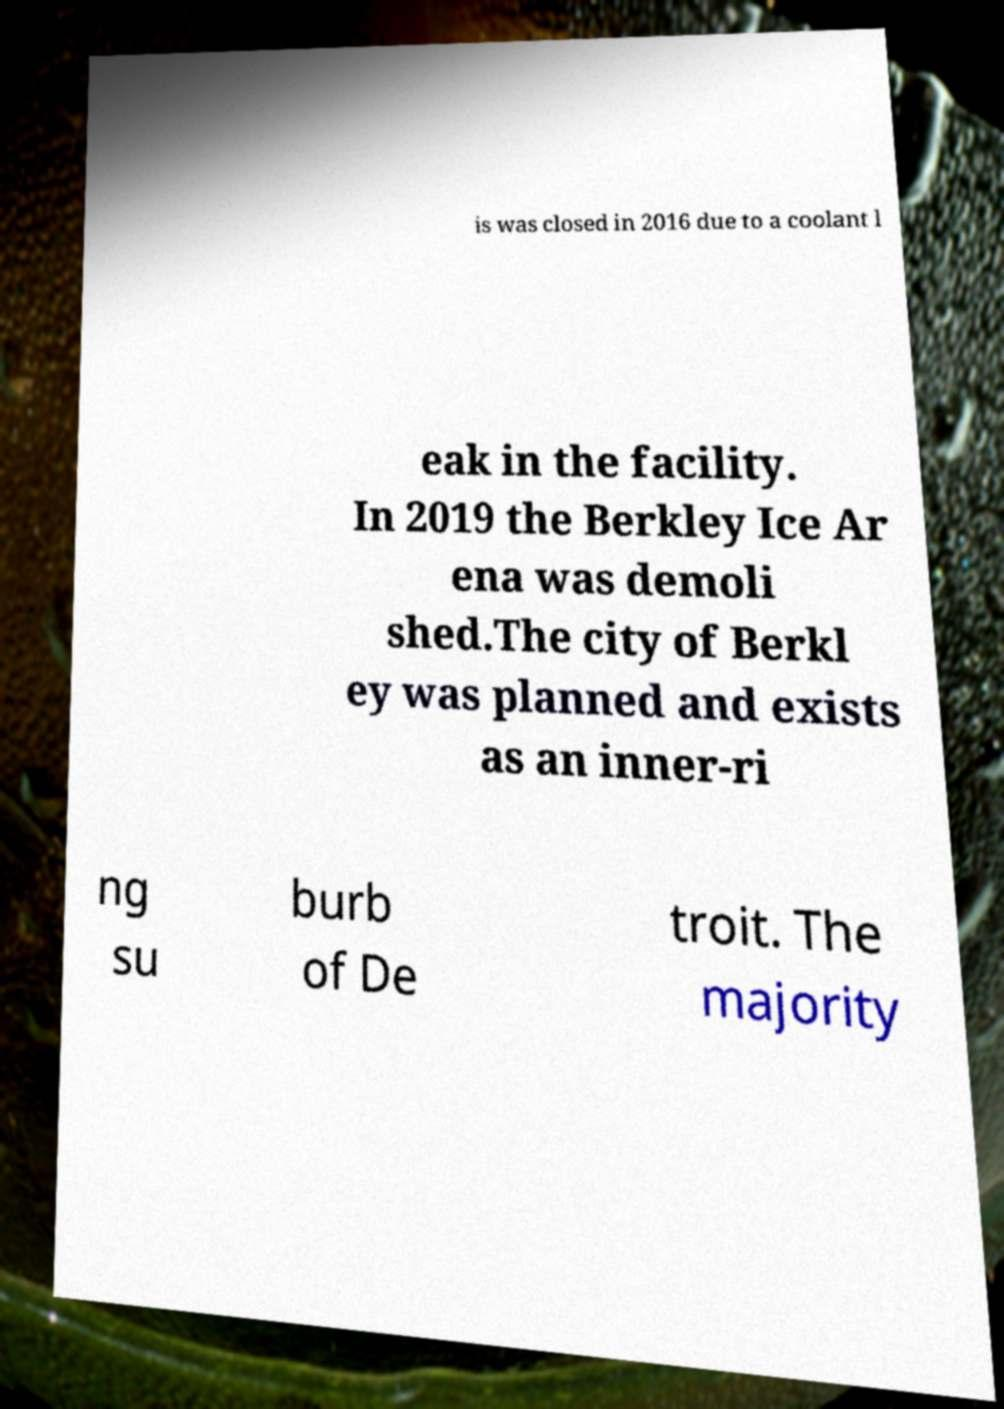Please identify and transcribe the text found in this image. is was closed in 2016 due to a coolant l eak in the facility. In 2019 the Berkley Ice Ar ena was demoli shed.The city of Berkl ey was planned and exists as an inner-ri ng su burb of De troit. The majority 